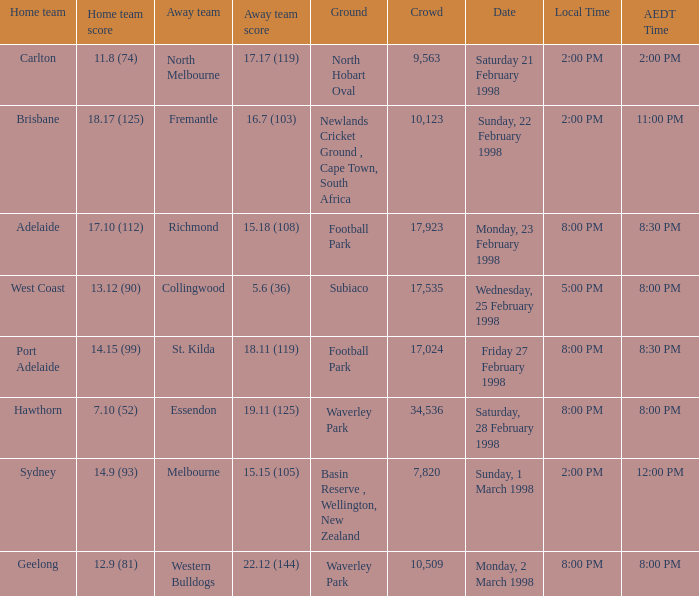Name the Away team which has a Ground of waverley park, and a Home team of hawthorn? Essendon. 